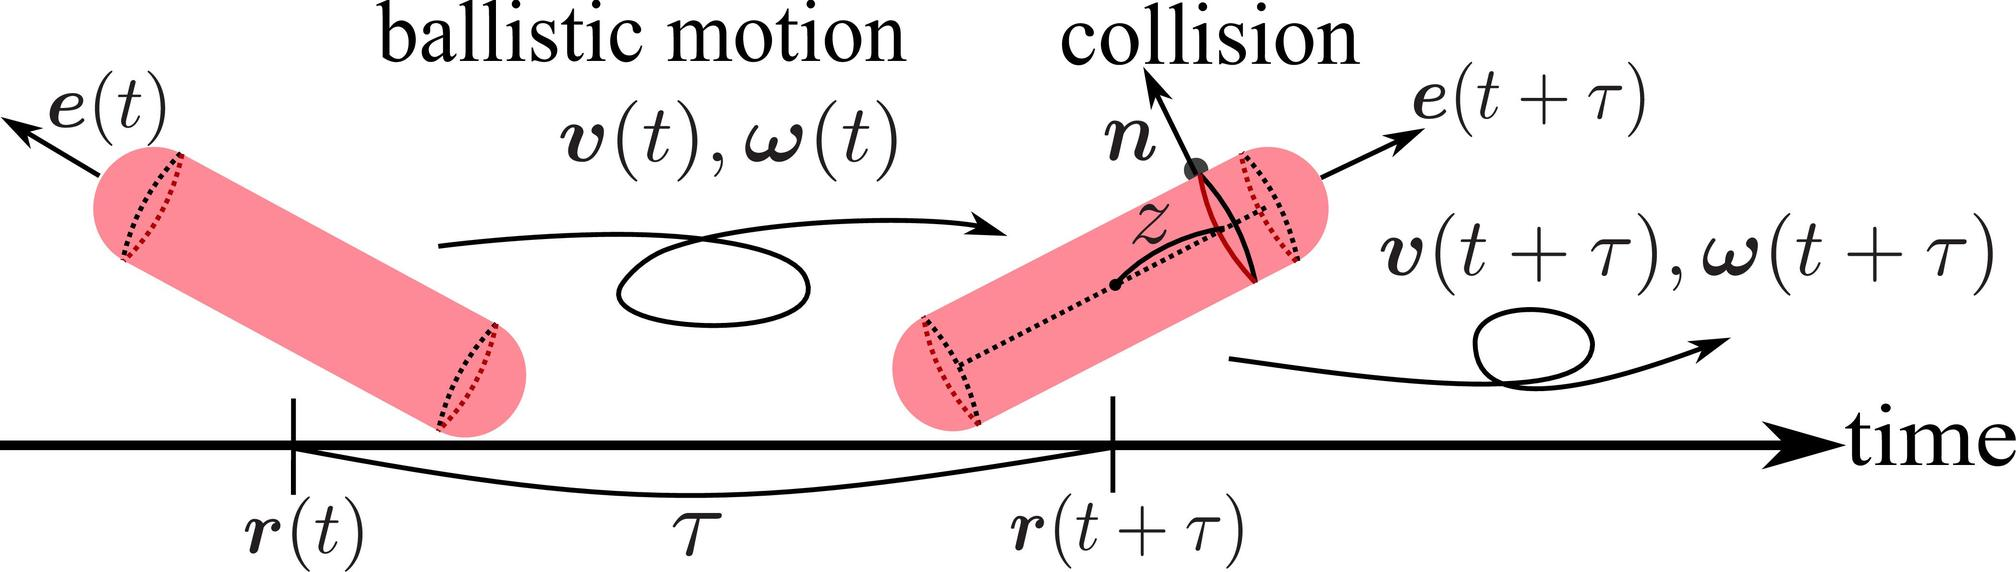Based on the figure, which vector represents the change in orientation of the cylinder as a result of the collision? A. r(t + τ) - r(t) B. e(t + τ) - e(t) C. v(t + τ) - v(t) D. ω(t + τ) - ω(t) The vector e(t) represents the orientation of the cylinder at time t. The figure shows e(t) at the start of the ballistic motion and e(t + τ) after the collision, indicating the change in orientation of the cylinder as a result of the collision. Therefore, e(t + τ) - e(t) represents this change. Therefore, the correct answer is B. 